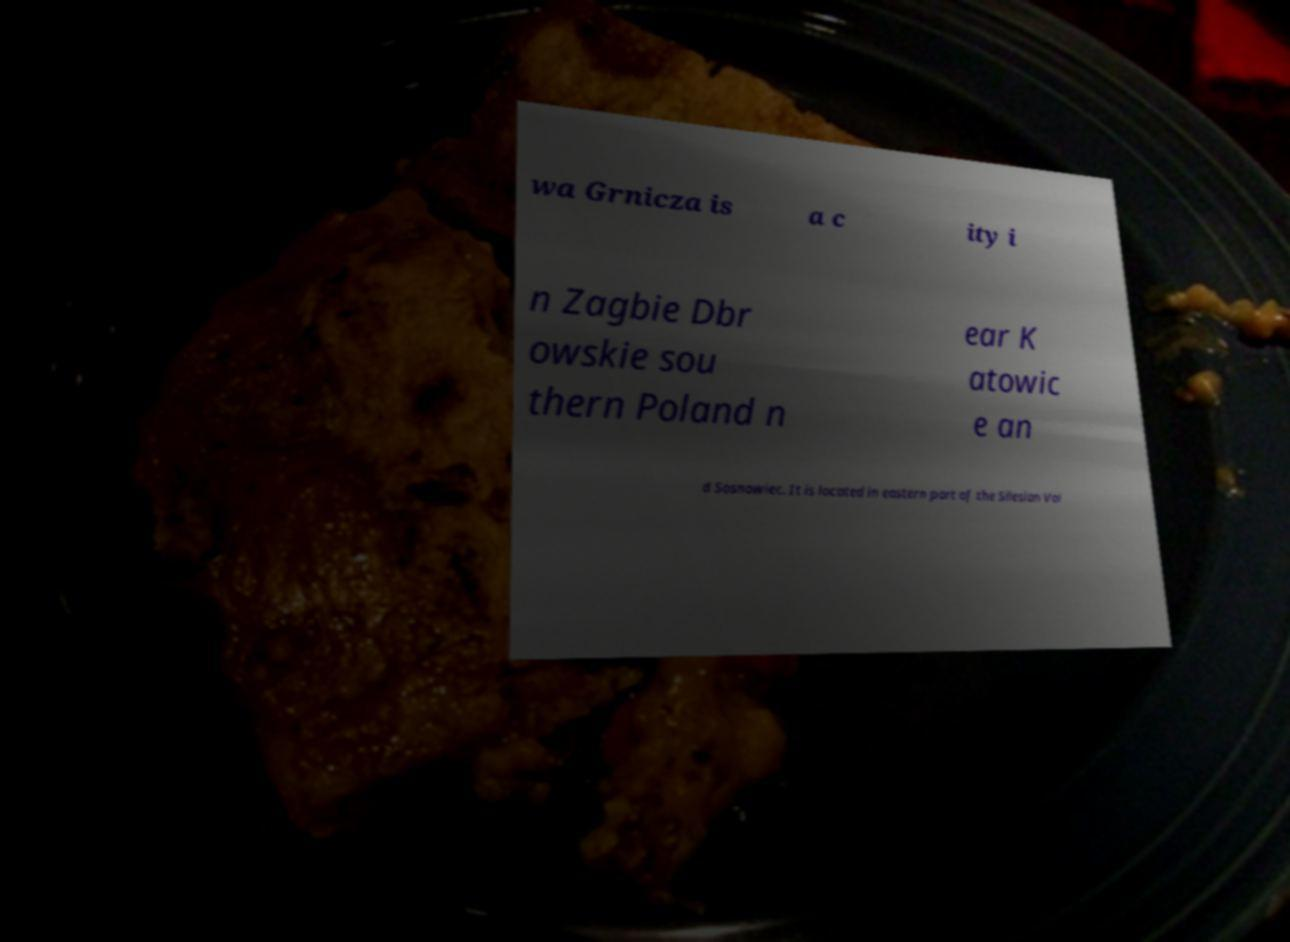Could you extract and type out the text from this image? wa Grnicza is a c ity i n Zagbie Dbr owskie sou thern Poland n ear K atowic e an d Sosnowiec. It is located in eastern part of the Silesian Voi 